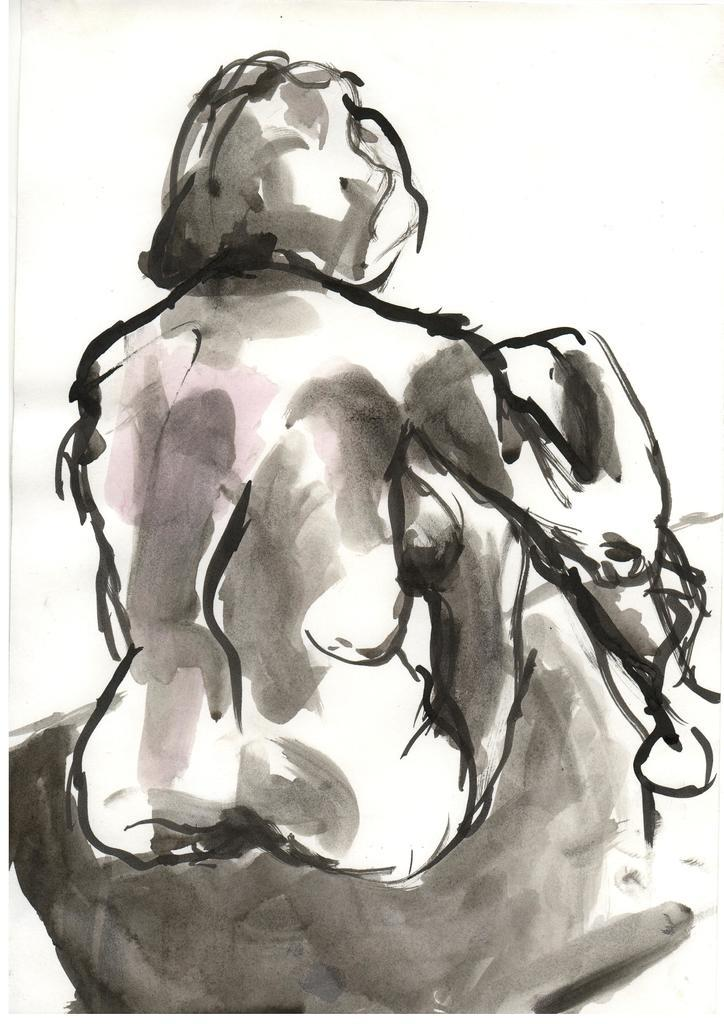What is the main subject of the picture? The main subject of the picture is a sketch. What type of chain can be seen connecting the clouds in the image? There is no chain or clouds present in the image; it only contains a sketch. 